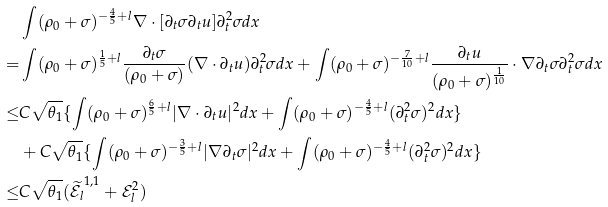<formula> <loc_0><loc_0><loc_500><loc_500>& \int ( \rho _ { 0 } + \sigma ) ^ { - \frac { 4 } { 5 } + l } \nabla \cdot [ \partial _ { t } \sigma \partial _ { t } u ] \partial _ { t } ^ { 2 } \sigma d x \\ = & \int ( \rho _ { 0 } + \sigma ) ^ { \frac { 1 } { 5 } + l } \frac { \partial _ { t } \sigma } { ( \rho _ { 0 } + \sigma ) } ( \nabla \cdot \partial _ { t } u ) \partial _ { t } ^ { 2 } \sigma d x + \int ( \rho _ { 0 } + \sigma ) ^ { - \frac { 7 } { 1 0 } + l } \frac { \partial _ { t } u } { ( \rho _ { 0 } + \sigma ) ^ { \frac { 1 } { 1 0 } } } \cdot \nabla \partial _ { t } \sigma \partial _ { t } ^ { 2 } \sigma d x \\ \leq & C \sqrt { \theta _ { 1 } } \{ \int ( \rho _ { 0 } + \sigma ) ^ { \frac { 6 } { 5 } + l } | \nabla \cdot \partial _ { t } u | ^ { 2 } d x + \int ( \rho _ { 0 } + \sigma ) ^ { - \frac { 4 } { 5 } + l } ( \partial _ { t } ^ { 2 } \sigma ) ^ { 2 } d x \} \\ & + C \sqrt { \theta _ { 1 } } \{ \int ( \rho _ { 0 } + \sigma ) ^ { - \frac { 3 } { 5 } + l } | \nabla \partial _ { t } \sigma | ^ { 2 } d x + \int ( \rho _ { 0 } + \sigma ) ^ { - \frac { 4 } { 5 } + l } ( \partial _ { t } ^ { 2 } \sigma ) ^ { 2 } d x \} \\ \leq & C \sqrt { \theta _ { 1 } } ( \widetilde { \mathcal { E } _ { l } } ^ { 1 , 1 } + \mathcal { E } _ { l } ^ { 2 } ) \\</formula> 